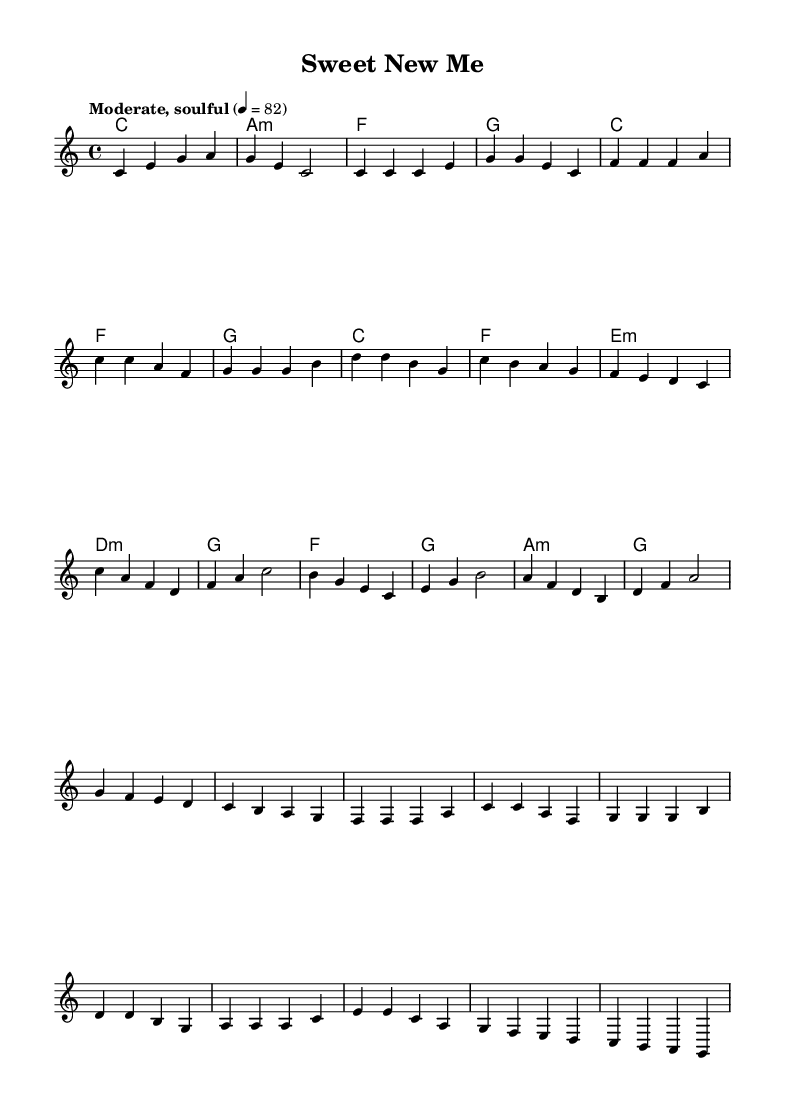What is the key signature of this music? The key signature is specified at the beginning of the score. It shows no sharps or flats, indicating that the piece is in C major.
Answer: C major What is the time signature? The time signature is located at the beginning of the score, which in this case is 4/4, meaning there are four beats in each measure, and each quarter note gets one beat.
Answer: 4/4 What is the tempo marking for the piece? The tempo marking can be found in the header section of the score; it indicates the piece should be played at a moderate pace of 82 beats per minute.
Answer: Moderate, soulful 4 = 82 How many measures are there in the chorus? Counting the measures in the chorus section of the score, it consists of four measures total, which are set apart under the corresponding lyric lines.
Answer: 4 What is the lyrical theme reflected in the lyrics? Analyzing the lyrics reveals that they convey a theme of personal strength and embracing lifestyle changes, particularly in the context of health and self-acceptance.
Answer: Strength in lifestyle changes Which chord is played during the first measure of the chorus? The first measure of the chorus has the chord marked above the staff, which shows the harmonic progression; in this case, it is F major.
Answer: F What emotional tone is conveyed in the melody of this music? The melody features rising and falling pitches that evoke a sense of hope and determination, which aligns with the song's themes of empowerment and resilience in lifestyle changes.
Answer: Hopeful 